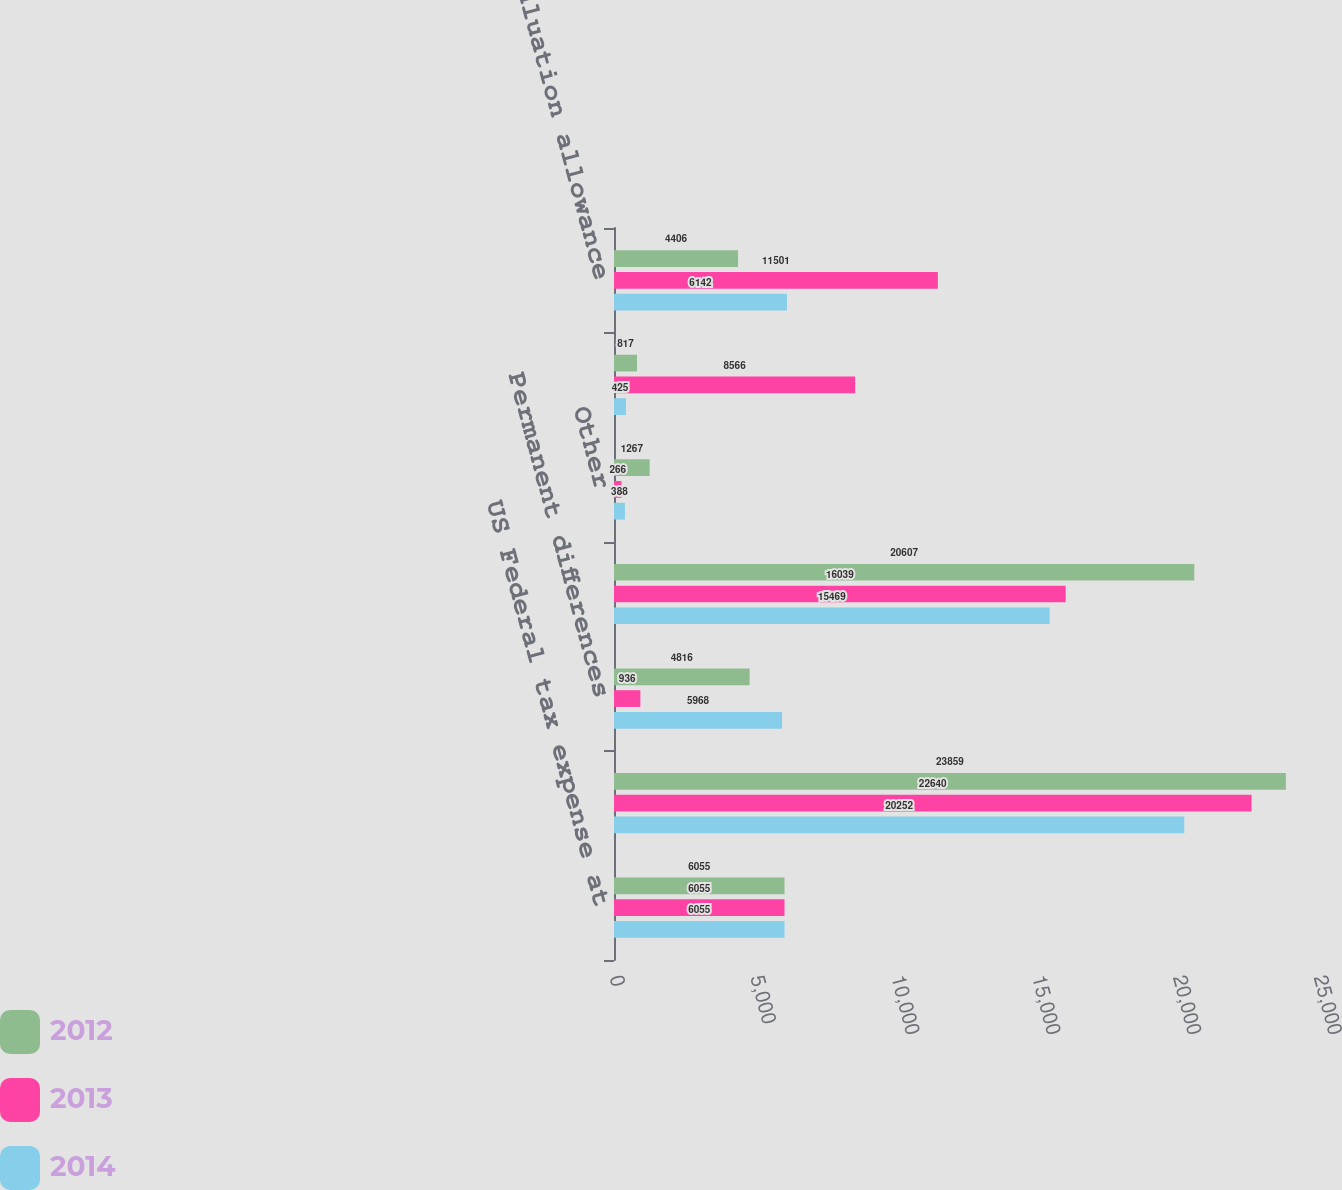Convert chart to OTSL. <chart><loc_0><loc_0><loc_500><loc_500><stacked_bar_chart><ecel><fcel>US Federal tax expense at<fcel>State income taxes net of<fcel>Permanent differences<fcel>Domestic production deduction<fcel>Other<fcel>Foreign rate differential<fcel>Valuation allowance<nl><fcel>2012<fcel>6055<fcel>23859<fcel>4816<fcel>20607<fcel>1267<fcel>817<fcel>4406<nl><fcel>2013<fcel>6055<fcel>22640<fcel>936<fcel>16039<fcel>266<fcel>8566<fcel>11501<nl><fcel>2014<fcel>6055<fcel>20252<fcel>5968<fcel>15469<fcel>388<fcel>425<fcel>6142<nl></chart> 